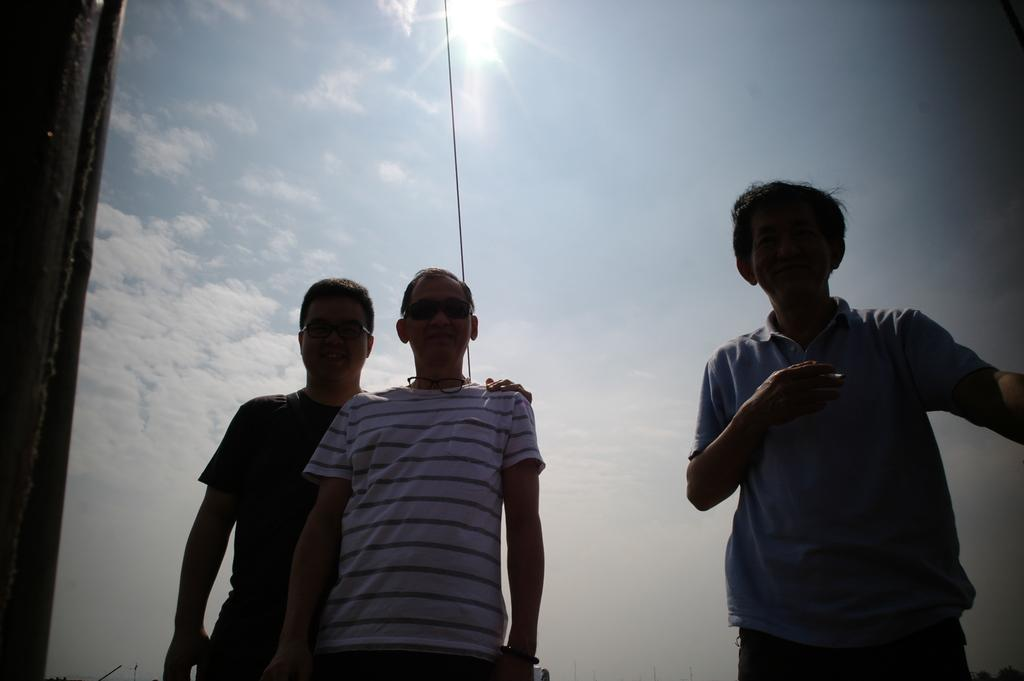How many people are in the group that is visible in the image? There is a group of people in the image, but the exact number is not specified. What can be seen on some of the people's faces in the image? Some people in the group are wearing spectacles. What is visible in the background of the image? There are clouds, a cable, and the sun visible in the background of the image. What type of rice is being served as an example in the image? There is no rice present in the image, and therefore no such example can be observed. 